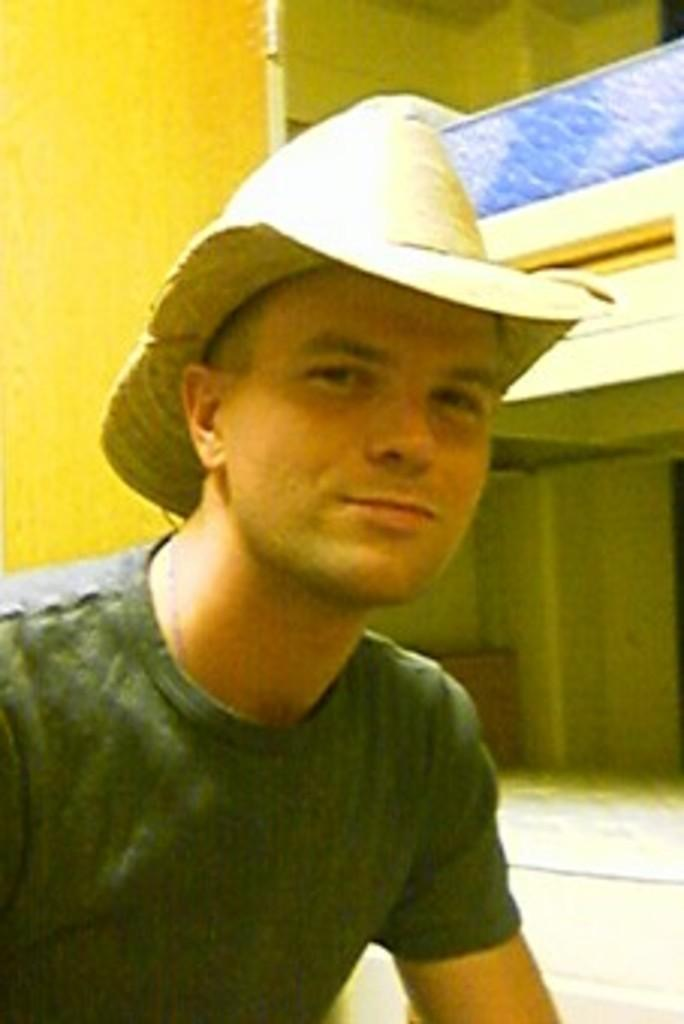Who is present in the image? There is a man in the image. What is the man wearing on his head? The man is wearing a hat. What is the man's facial expression in the image? The man is smiling. What can be seen behind the man in the image? There is a wall in the background of the image. What else is visible in the background of the image? There are objects visible in the background of the image. What type of punishment is the man receiving in the image? There is no indication in the image that the man is receiving any punishment; he is simply smiling. What scent can be detected from the man in the image? There is no information about the man's scent in the image. 